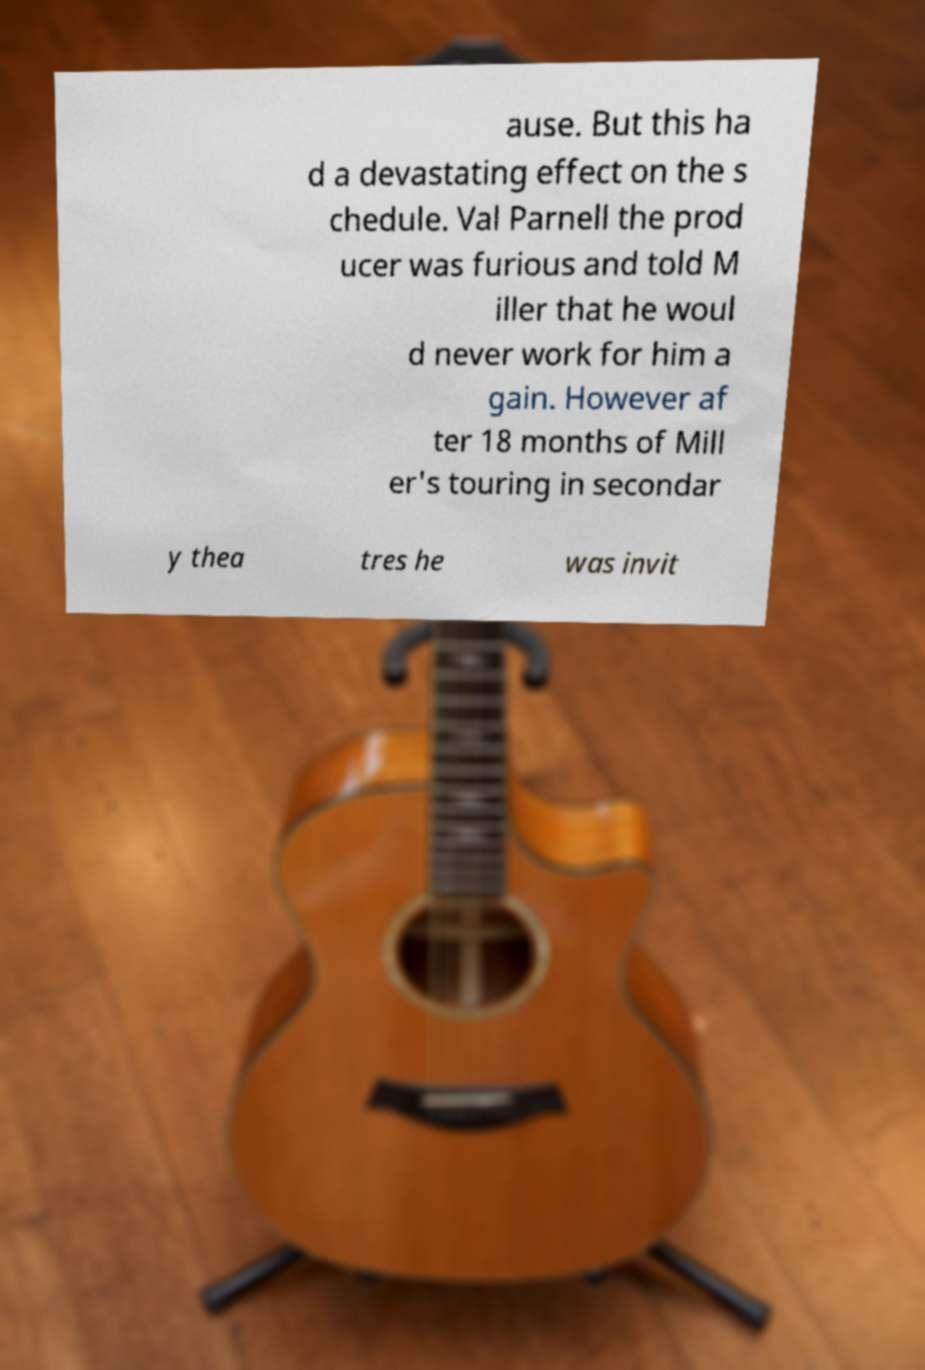I need the written content from this picture converted into text. Can you do that? ause. But this ha d a devastating effect on the s chedule. Val Parnell the prod ucer was furious and told M iller that he woul d never work for him a gain. However af ter 18 months of Mill er's touring in secondar y thea tres he was invit 